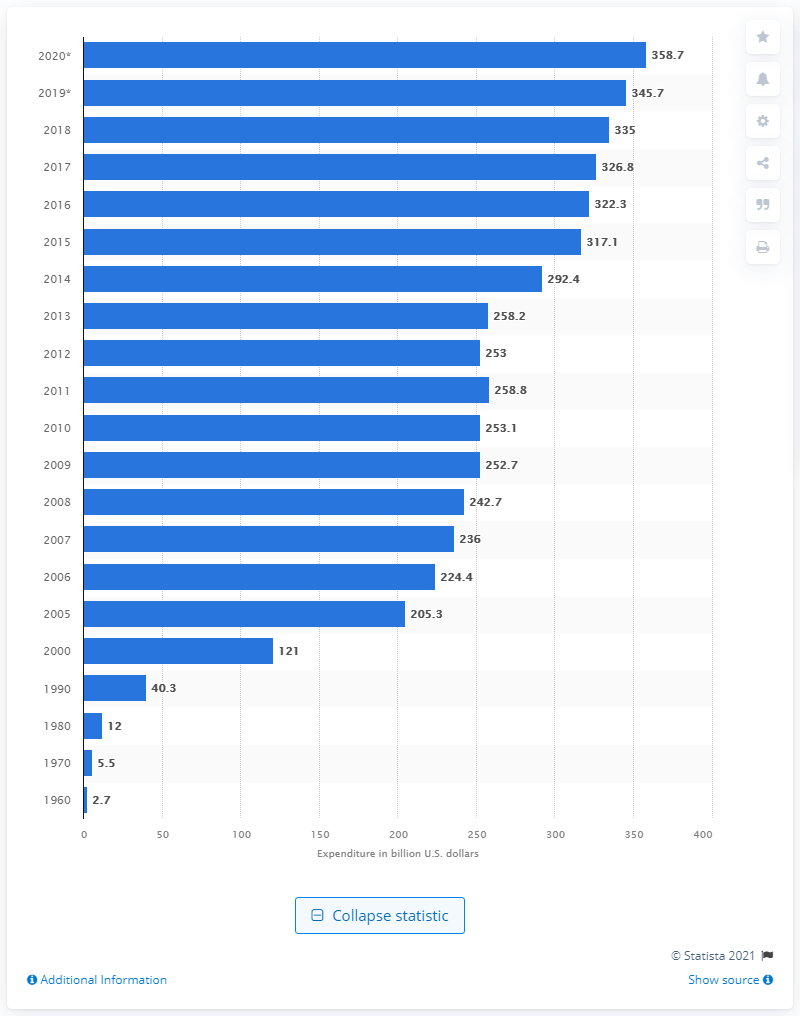List a handful of essential elements in this visual. In 2018, the United States spent 335 billion dollars on prescription drug expenditure. 